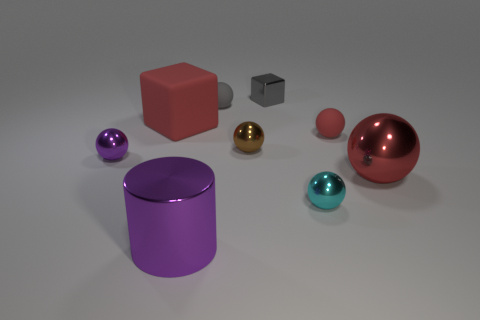Add 1 purple metallic cubes. How many objects exist? 10 Subtract 1 spheres. How many spheres are left? 5 Subtract all red blocks. Subtract all blue spheres. How many blocks are left? 1 Subtract all gray blocks. How many yellow spheres are left? 0 Subtract all cyan blocks. Subtract all small red spheres. How many objects are left? 8 Add 8 big red shiny balls. How many big red shiny balls are left? 9 Add 6 cyan metallic things. How many cyan metallic things exist? 7 Subtract all gray spheres. How many spheres are left? 5 Subtract all red metal spheres. How many spheres are left? 5 Subtract 0 red cylinders. How many objects are left? 9 